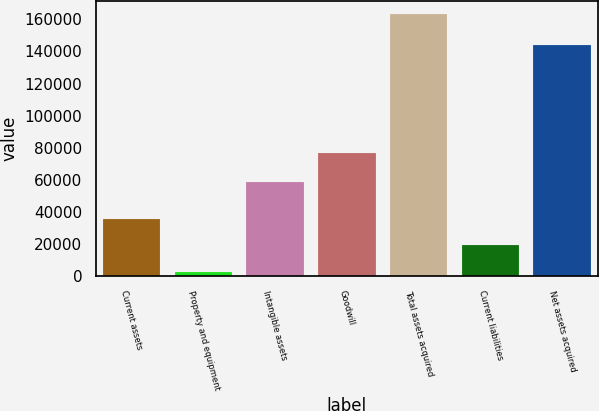<chart> <loc_0><loc_0><loc_500><loc_500><bar_chart><fcel>Current assets<fcel>Property and equipment<fcel>Intangible assets<fcel>Goodwill<fcel>Total assets acquired<fcel>Current liabilities<fcel>Net assets acquired<nl><fcel>35415<fcel>2601<fcel>58400<fcel>76693<fcel>163401<fcel>19335<fcel>144066<nl></chart> 